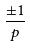Convert formula to latex. <formula><loc_0><loc_0><loc_500><loc_500>\frac { \pm 1 } { p }</formula> 